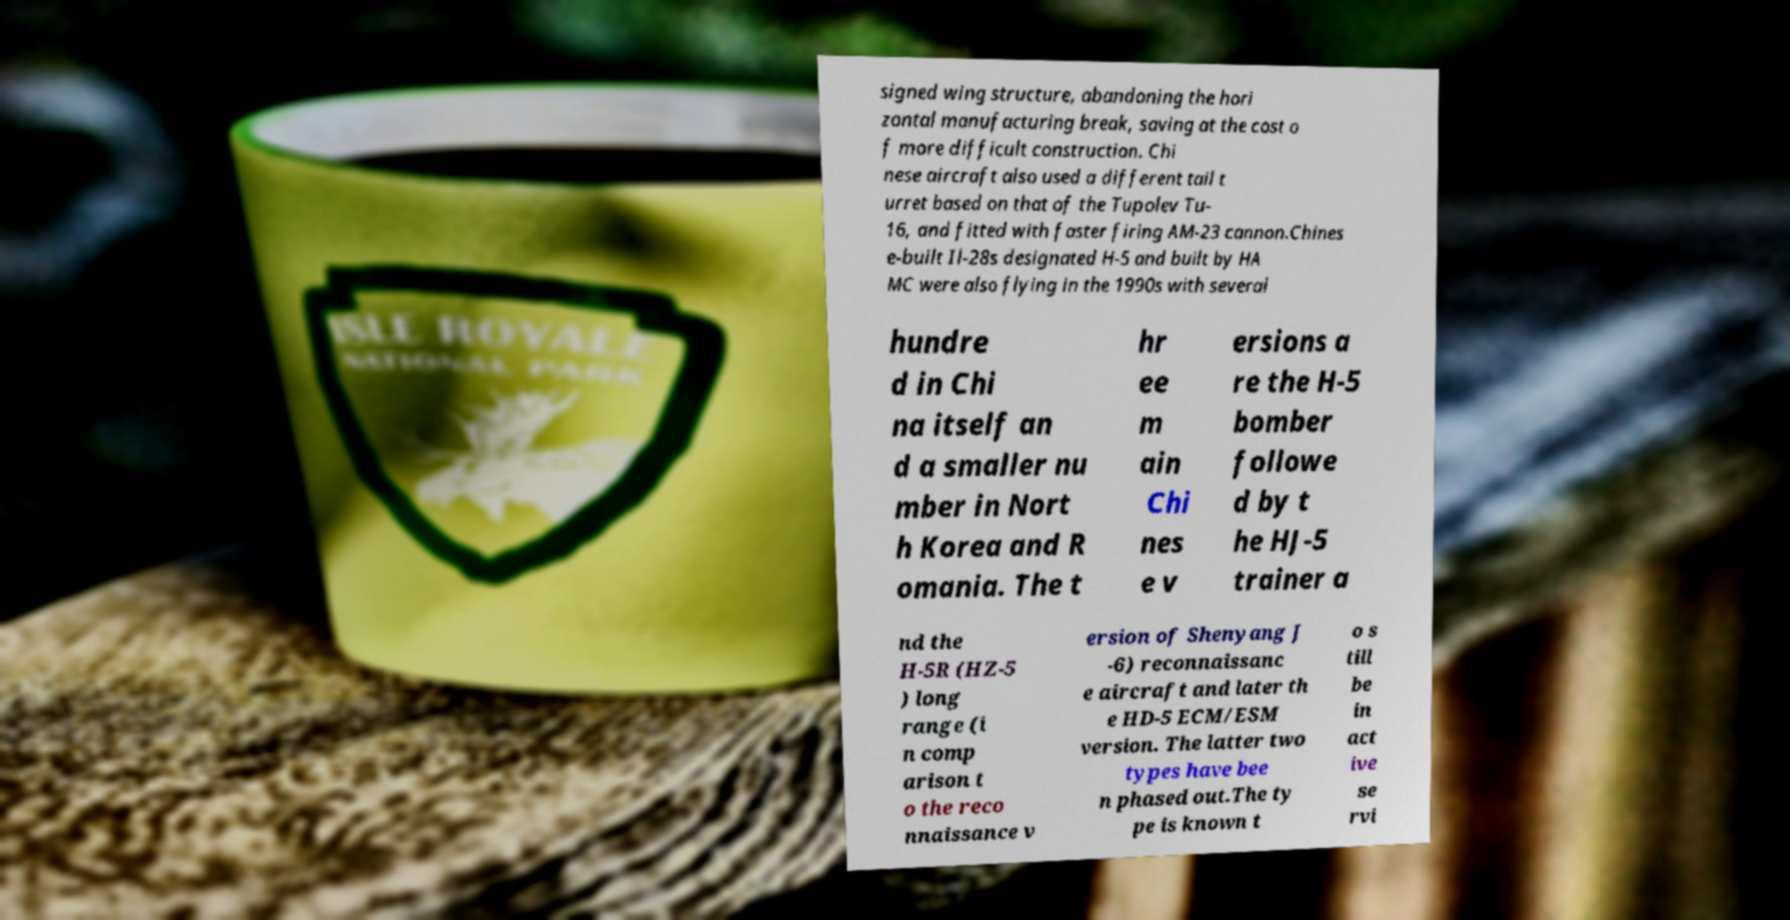Please identify and transcribe the text found in this image. signed wing structure, abandoning the hori zontal manufacturing break, saving at the cost o f more difficult construction. Chi nese aircraft also used a different tail t urret based on that of the Tupolev Tu- 16, and fitted with faster firing AM-23 cannon.Chines e-built Il-28s designated H-5 and built by HA MC were also flying in the 1990s with several hundre d in Chi na itself an d a smaller nu mber in Nort h Korea and R omania. The t hr ee m ain Chi nes e v ersions a re the H-5 bomber followe d by t he HJ-5 trainer a nd the H-5R (HZ-5 ) long range (i n comp arison t o the reco nnaissance v ersion of Shenyang J -6) reconnaissanc e aircraft and later th e HD-5 ECM/ESM version. The latter two types have bee n phased out.The ty pe is known t o s till be in act ive se rvi 